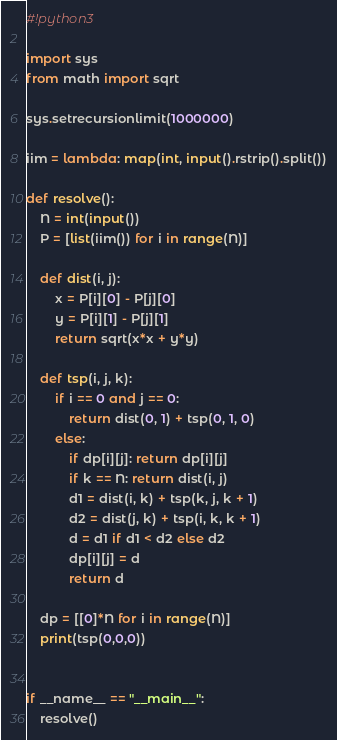<code> <loc_0><loc_0><loc_500><loc_500><_Python_>#!python3

import sys
from math import sqrt

sys.setrecursionlimit(1000000)

iim = lambda: map(int, input().rstrip().split())

def resolve():
    N = int(input())
    P = [list(iim()) for i in range(N)]

    def dist(i, j):
        x = P[i][0] - P[j][0]
        y = P[i][1] - P[j][1]
        return sqrt(x*x + y*y)

    def tsp(i, j, k):
        if i == 0 and j == 0:
            return dist(0, 1) + tsp(0, 1, 0)
        else:
            if dp[i][j]: return dp[i][j]
            if k == N: return dist(i, j)
            d1 = dist(i, k) + tsp(k, j, k + 1)
            d2 = dist(j, k) + tsp(i, k, k + 1)
            d = d1 if d1 < d2 else d2
            dp[i][j] = d
            return d

    dp = [[0]*N for i in range(N)]
    print(tsp(0,0,0))


if __name__ == "__main__":
    resolve()

</code> 